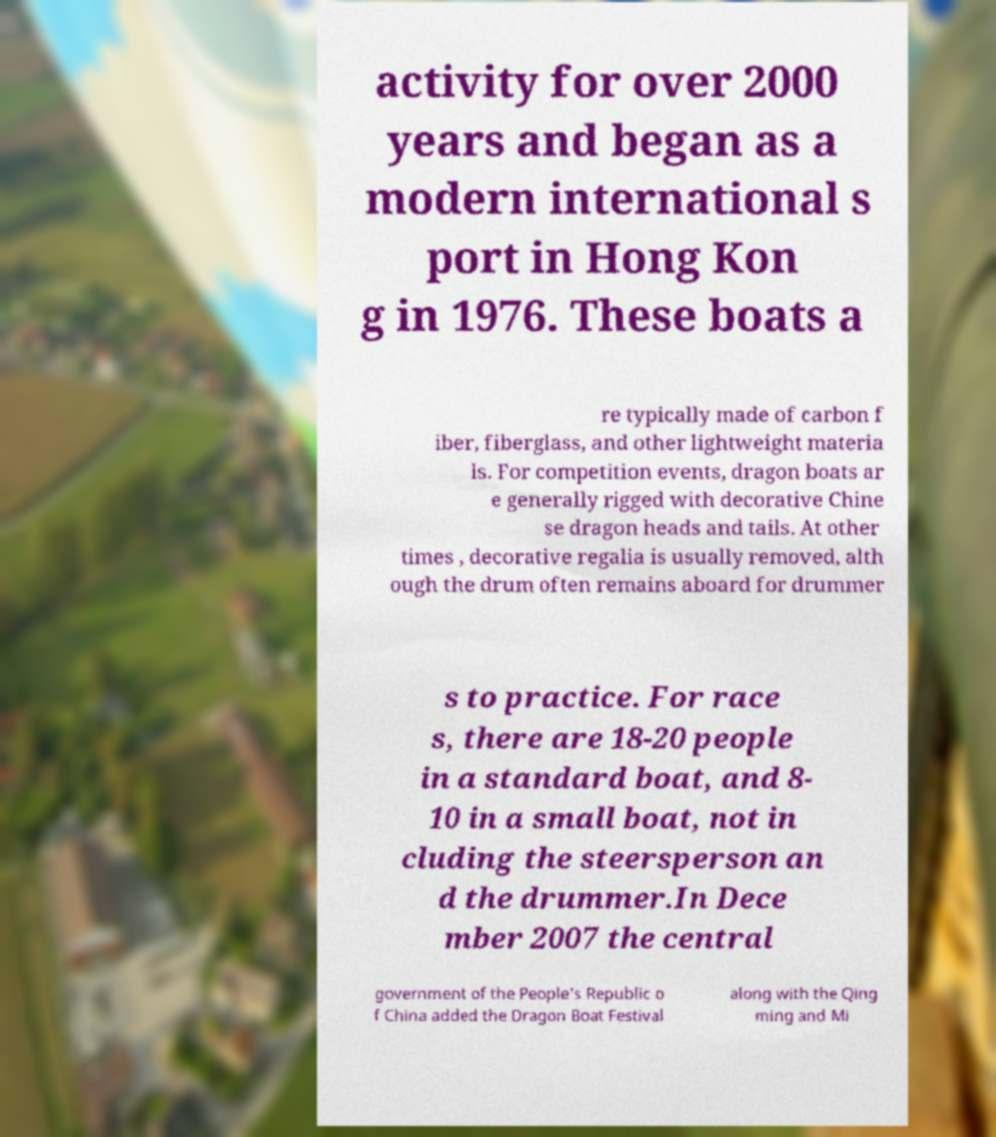Please identify and transcribe the text found in this image. activity for over 2000 years and began as a modern international s port in Hong Kon g in 1976. These boats a re typically made of carbon f iber, fiberglass, and other lightweight materia ls. For competition events, dragon boats ar e generally rigged with decorative Chine se dragon heads and tails. At other times , decorative regalia is usually removed, alth ough the drum often remains aboard for drummer s to practice. For race s, there are 18-20 people in a standard boat, and 8- 10 in a small boat, not in cluding the steersperson an d the drummer.In Dece mber 2007 the central government of the People's Republic o f China added the Dragon Boat Festival along with the Qing ming and Mi 